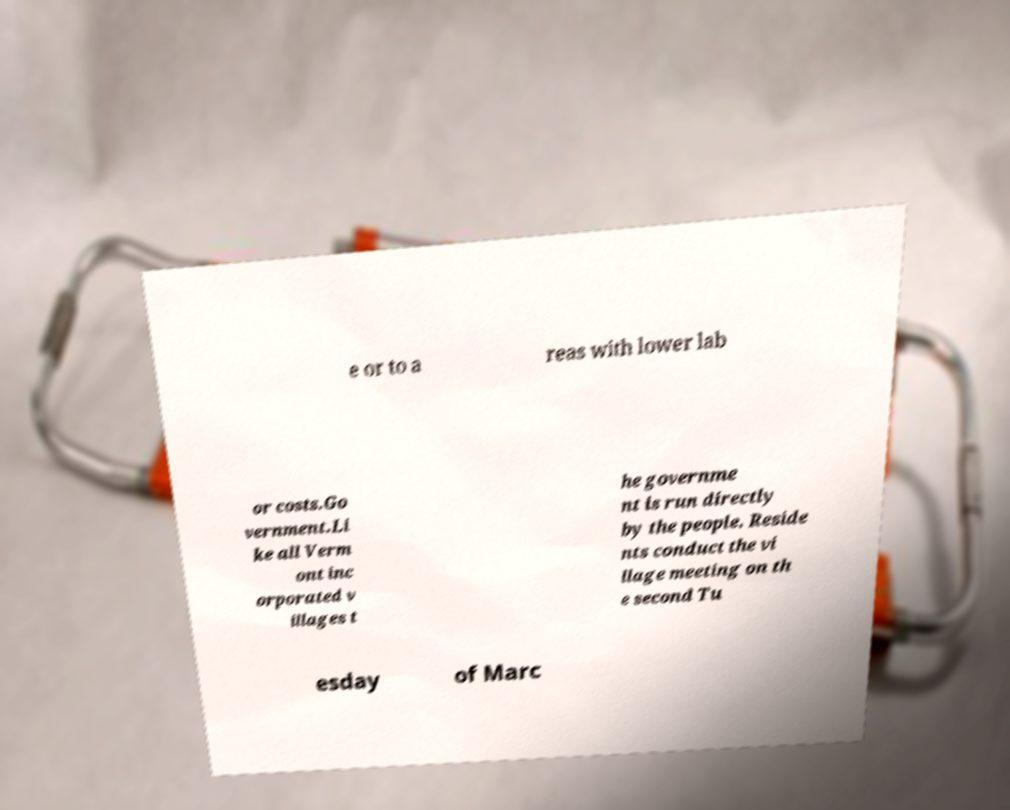For documentation purposes, I need the text within this image transcribed. Could you provide that? e or to a reas with lower lab or costs.Go vernment.Li ke all Verm ont inc orporated v illages t he governme nt is run directly by the people. Reside nts conduct the vi llage meeting on th e second Tu esday of Marc 